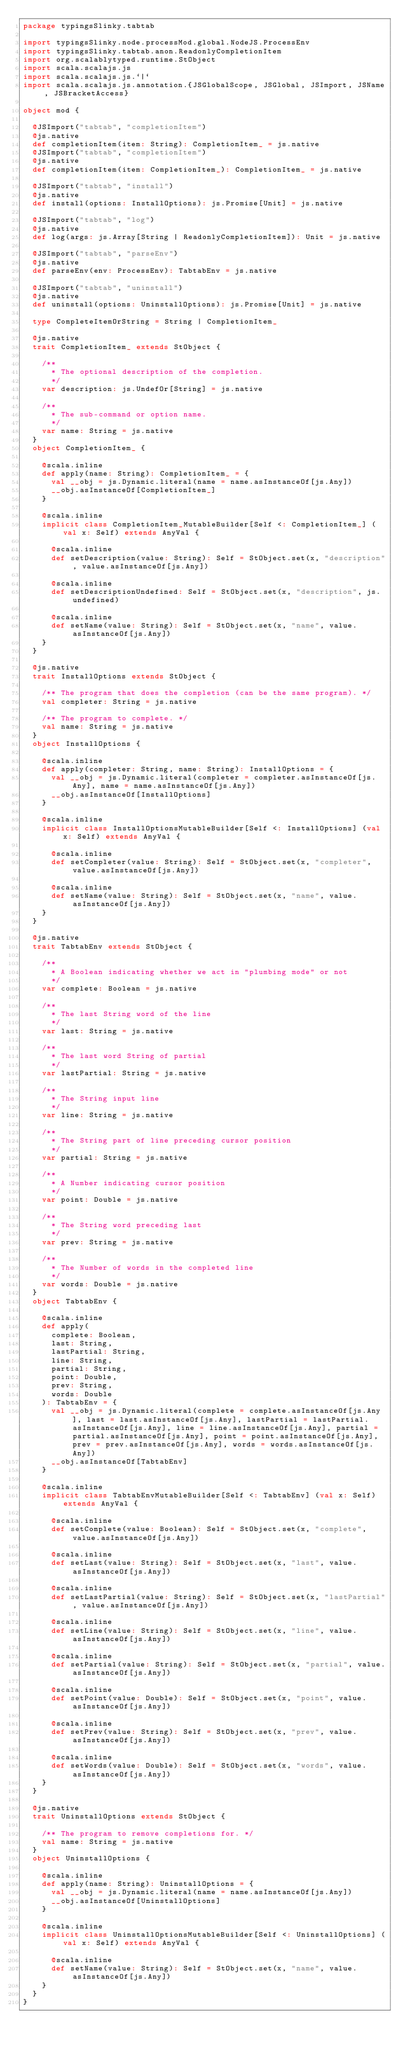<code> <loc_0><loc_0><loc_500><loc_500><_Scala_>package typingsSlinky.tabtab

import typingsSlinky.node.processMod.global.NodeJS.ProcessEnv
import typingsSlinky.tabtab.anon.ReadonlyCompletionItem
import org.scalablytyped.runtime.StObject
import scala.scalajs.js
import scala.scalajs.js.`|`
import scala.scalajs.js.annotation.{JSGlobalScope, JSGlobal, JSImport, JSName, JSBracketAccess}

object mod {
  
  @JSImport("tabtab", "completionItem")
  @js.native
  def completionItem(item: String): CompletionItem_ = js.native
  @JSImport("tabtab", "completionItem")
  @js.native
  def completionItem(item: CompletionItem_): CompletionItem_ = js.native
  
  @JSImport("tabtab", "install")
  @js.native
  def install(options: InstallOptions): js.Promise[Unit] = js.native
  
  @JSImport("tabtab", "log")
  @js.native
  def log(args: js.Array[String | ReadonlyCompletionItem]): Unit = js.native
  
  @JSImport("tabtab", "parseEnv")
  @js.native
  def parseEnv(env: ProcessEnv): TabtabEnv = js.native
  
  @JSImport("tabtab", "uninstall")
  @js.native
  def uninstall(options: UninstallOptions): js.Promise[Unit] = js.native
  
  type CompleteItemOrString = String | CompletionItem_
  
  @js.native
  trait CompletionItem_ extends StObject {
    
    /**
      * The optional description of the completion.
      */
    var description: js.UndefOr[String] = js.native
    
    /**
      * The sub-command or option name.
      */
    var name: String = js.native
  }
  object CompletionItem_ {
    
    @scala.inline
    def apply(name: String): CompletionItem_ = {
      val __obj = js.Dynamic.literal(name = name.asInstanceOf[js.Any])
      __obj.asInstanceOf[CompletionItem_]
    }
    
    @scala.inline
    implicit class CompletionItem_MutableBuilder[Self <: CompletionItem_] (val x: Self) extends AnyVal {
      
      @scala.inline
      def setDescription(value: String): Self = StObject.set(x, "description", value.asInstanceOf[js.Any])
      
      @scala.inline
      def setDescriptionUndefined: Self = StObject.set(x, "description", js.undefined)
      
      @scala.inline
      def setName(value: String): Self = StObject.set(x, "name", value.asInstanceOf[js.Any])
    }
  }
  
  @js.native
  trait InstallOptions extends StObject {
    
    /** The program that does the completion (can be the same program). */
    val completer: String = js.native
    
    /** The program to complete. */
    val name: String = js.native
  }
  object InstallOptions {
    
    @scala.inline
    def apply(completer: String, name: String): InstallOptions = {
      val __obj = js.Dynamic.literal(completer = completer.asInstanceOf[js.Any], name = name.asInstanceOf[js.Any])
      __obj.asInstanceOf[InstallOptions]
    }
    
    @scala.inline
    implicit class InstallOptionsMutableBuilder[Self <: InstallOptions] (val x: Self) extends AnyVal {
      
      @scala.inline
      def setCompleter(value: String): Self = StObject.set(x, "completer", value.asInstanceOf[js.Any])
      
      @scala.inline
      def setName(value: String): Self = StObject.set(x, "name", value.asInstanceOf[js.Any])
    }
  }
  
  @js.native
  trait TabtabEnv extends StObject {
    
    /**
      * A Boolean indicating whether we act in "plumbing mode" or not
      */
    var complete: Boolean = js.native
    
    /**
      * The last String word of the line
      */
    var last: String = js.native
    
    /**
      * The last word String of partial
      */
    var lastPartial: String = js.native
    
    /**
      * The String input line
      */
    var line: String = js.native
    
    /**
      * The String part of line preceding cursor position
      */
    var partial: String = js.native
    
    /**
      * A Number indicating cursor position
      */
    var point: Double = js.native
    
    /**
      * The String word preceding last
      */
    var prev: String = js.native
    
    /**
      * The Number of words in the completed line
      */
    var words: Double = js.native
  }
  object TabtabEnv {
    
    @scala.inline
    def apply(
      complete: Boolean,
      last: String,
      lastPartial: String,
      line: String,
      partial: String,
      point: Double,
      prev: String,
      words: Double
    ): TabtabEnv = {
      val __obj = js.Dynamic.literal(complete = complete.asInstanceOf[js.Any], last = last.asInstanceOf[js.Any], lastPartial = lastPartial.asInstanceOf[js.Any], line = line.asInstanceOf[js.Any], partial = partial.asInstanceOf[js.Any], point = point.asInstanceOf[js.Any], prev = prev.asInstanceOf[js.Any], words = words.asInstanceOf[js.Any])
      __obj.asInstanceOf[TabtabEnv]
    }
    
    @scala.inline
    implicit class TabtabEnvMutableBuilder[Self <: TabtabEnv] (val x: Self) extends AnyVal {
      
      @scala.inline
      def setComplete(value: Boolean): Self = StObject.set(x, "complete", value.asInstanceOf[js.Any])
      
      @scala.inline
      def setLast(value: String): Self = StObject.set(x, "last", value.asInstanceOf[js.Any])
      
      @scala.inline
      def setLastPartial(value: String): Self = StObject.set(x, "lastPartial", value.asInstanceOf[js.Any])
      
      @scala.inline
      def setLine(value: String): Self = StObject.set(x, "line", value.asInstanceOf[js.Any])
      
      @scala.inline
      def setPartial(value: String): Self = StObject.set(x, "partial", value.asInstanceOf[js.Any])
      
      @scala.inline
      def setPoint(value: Double): Self = StObject.set(x, "point", value.asInstanceOf[js.Any])
      
      @scala.inline
      def setPrev(value: String): Self = StObject.set(x, "prev", value.asInstanceOf[js.Any])
      
      @scala.inline
      def setWords(value: Double): Self = StObject.set(x, "words", value.asInstanceOf[js.Any])
    }
  }
  
  @js.native
  trait UninstallOptions extends StObject {
    
    /** The program to remove completions for. */
    val name: String = js.native
  }
  object UninstallOptions {
    
    @scala.inline
    def apply(name: String): UninstallOptions = {
      val __obj = js.Dynamic.literal(name = name.asInstanceOf[js.Any])
      __obj.asInstanceOf[UninstallOptions]
    }
    
    @scala.inline
    implicit class UninstallOptionsMutableBuilder[Self <: UninstallOptions] (val x: Self) extends AnyVal {
      
      @scala.inline
      def setName(value: String): Self = StObject.set(x, "name", value.asInstanceOf[js.Any])
    }
  }
}
</code> 